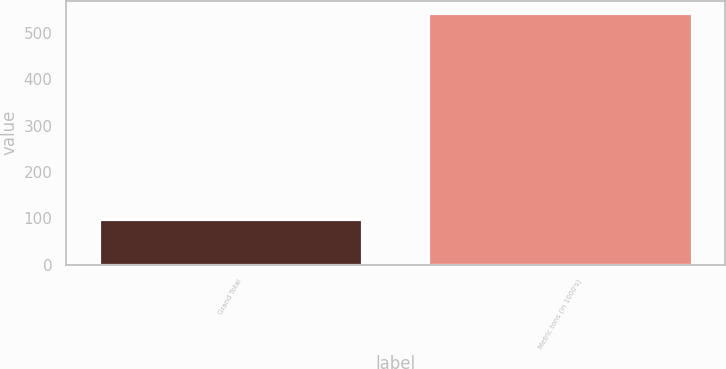Convert chart to OTSL. <chart><loc_0><loc_0><loc_500><loc_500><bar_chart><fcel>Grand Total<fcel>Metric tons (in 1000's)<nl><fcel>99<fcel>542<nl></chart> 